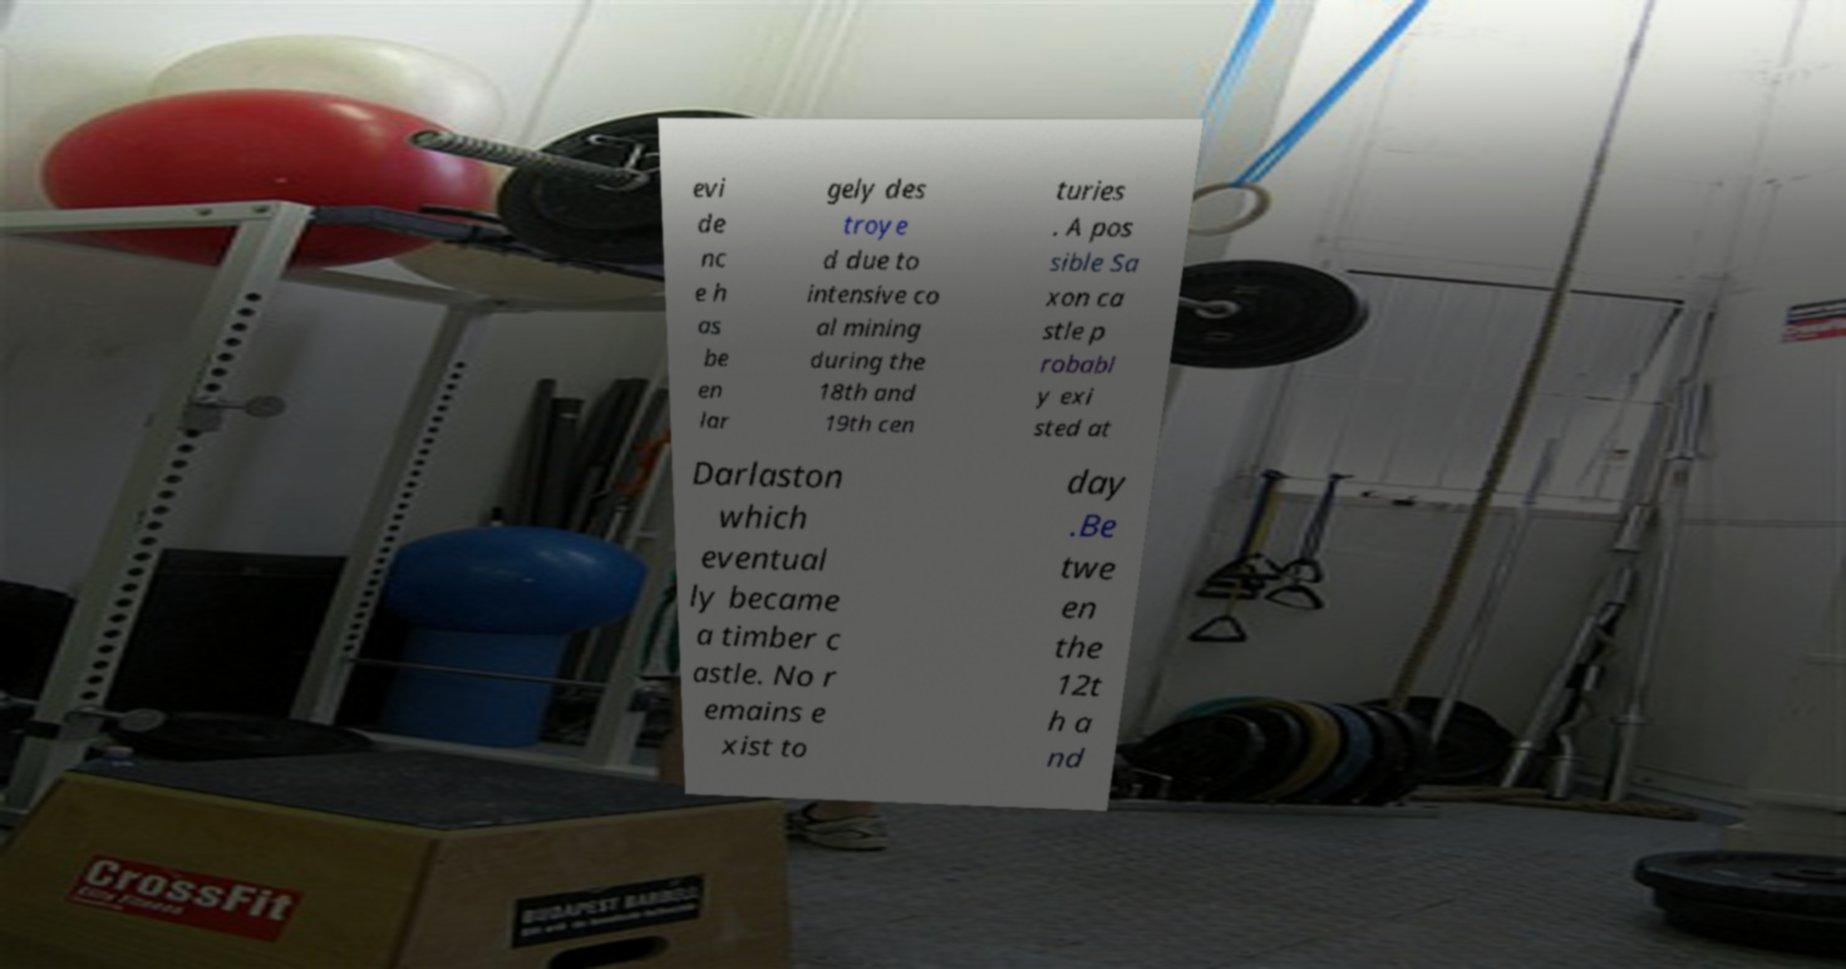Could you assist in decoding the text presented in this image and type it out clearly? evi de nc e h as be en lar gely des troye d due to intensive co al mining during the 18th and 19th cen turies . A pos sible Sa xon ca stle p robabl y exi sted at Darlaston which eventual ly became a timber c astle. No r emains e xist to day .Be twe en the 12t h a nd 